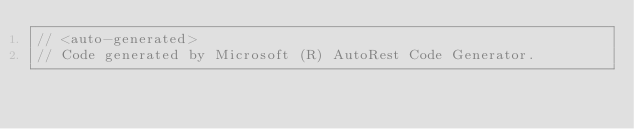<code> <loc_0><loc_0><loc_500><loc_500><_C#_>// <auto-generated>
// Code generated by Microsoft (R) AutoRest Code Generator.</code> 